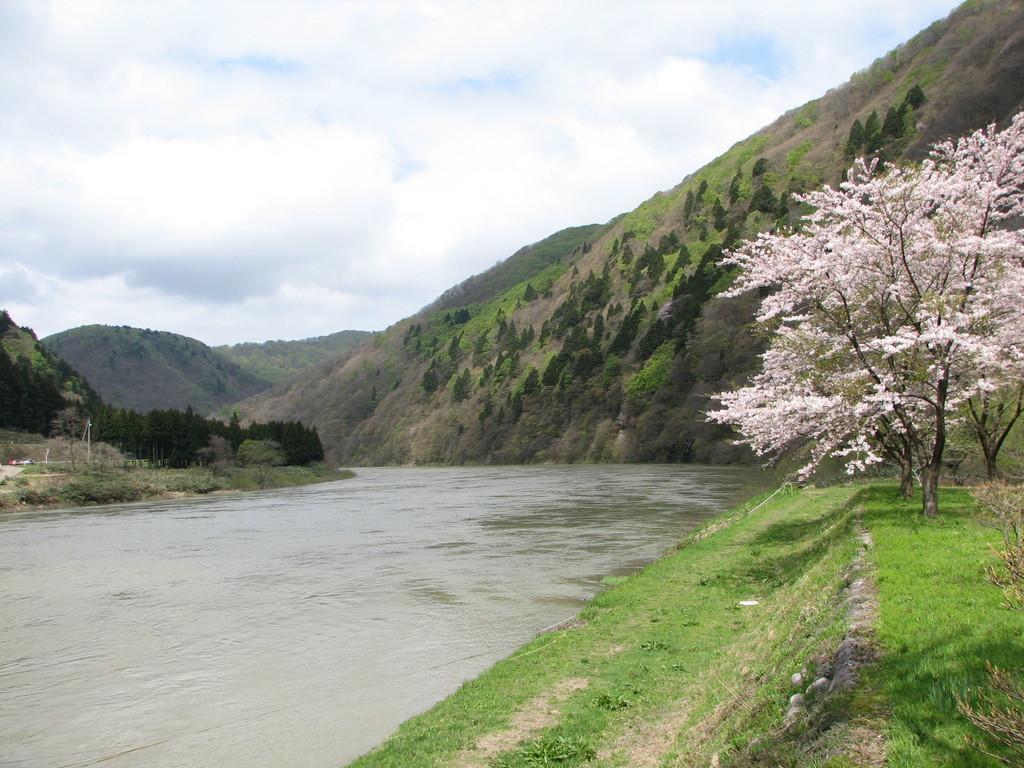How would you summarize this image in a sentence or two? In this picture I can see on the left side there is water, on the right side there are trees. In the background there are hills, at the top there is the sky. 